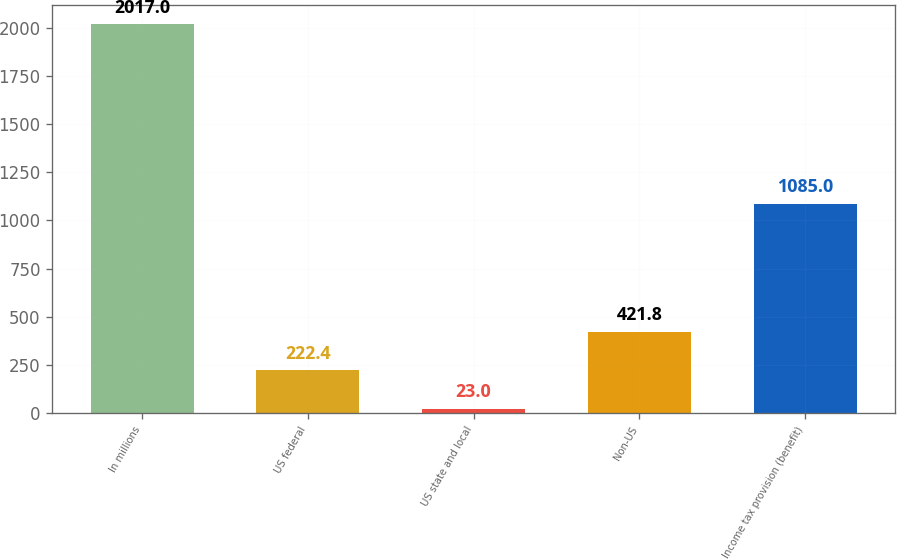Convert chart. <chart><loc_0><loc_0><loc_500><loc_500><bar_chart><fcel>In millions<fcel>US federal<fcel>US state and local<fcel>Non-US<fcel>Income tax provision (benefit)<nl><fcel>2017<fcel>222.4<fcel>23<fcel>421.8<fcel>1085<nl></chart> 